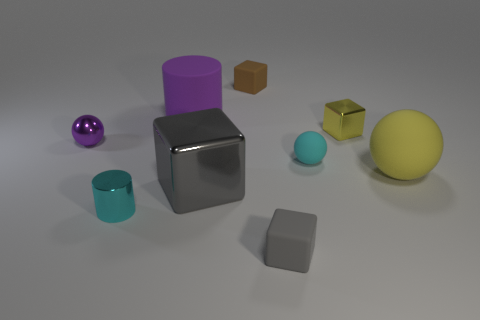There is a purple metal thing that is the same size as the cyan matte object; what shape is it? The purple metal object shares its cylindrical shape with the matte cyan object, both reflecting the simplicity and symmetry often found in geometric forms. 